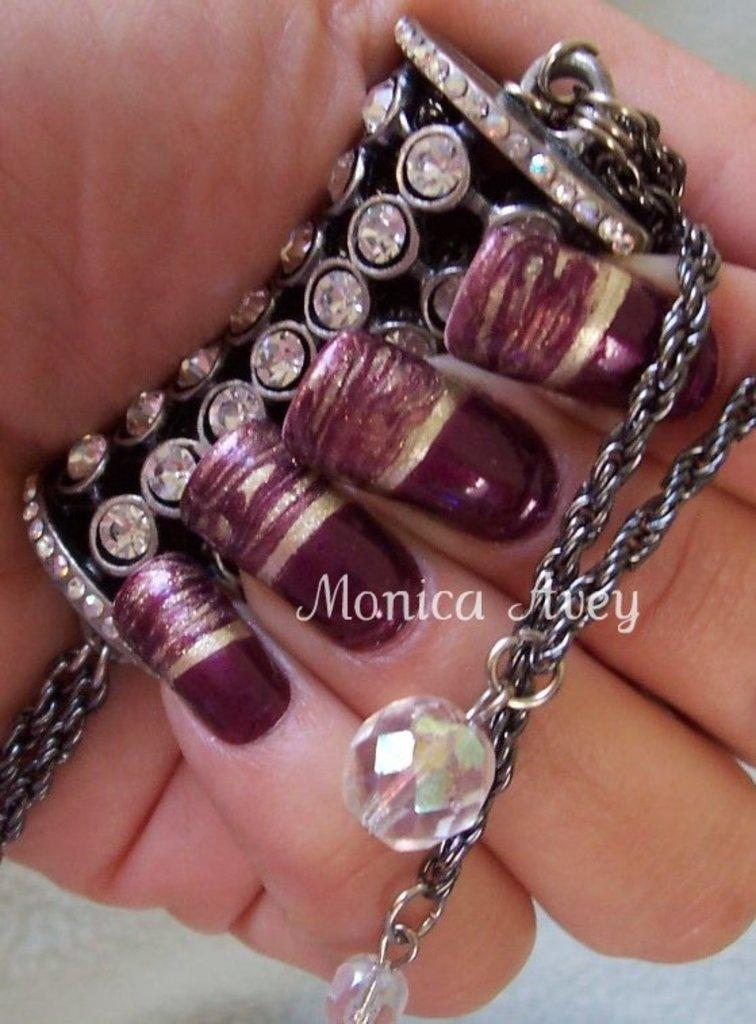What can be seen in the image? There is a hand in the image. What is the hand holding? The hand is holding a metal object. What type of beast is depicted in the image? There is no beast present in the image; it only features a hand holding a metal object. What type of drum is being played in the image? There is no drum present in the image; it only features a hand holding a metal object. 